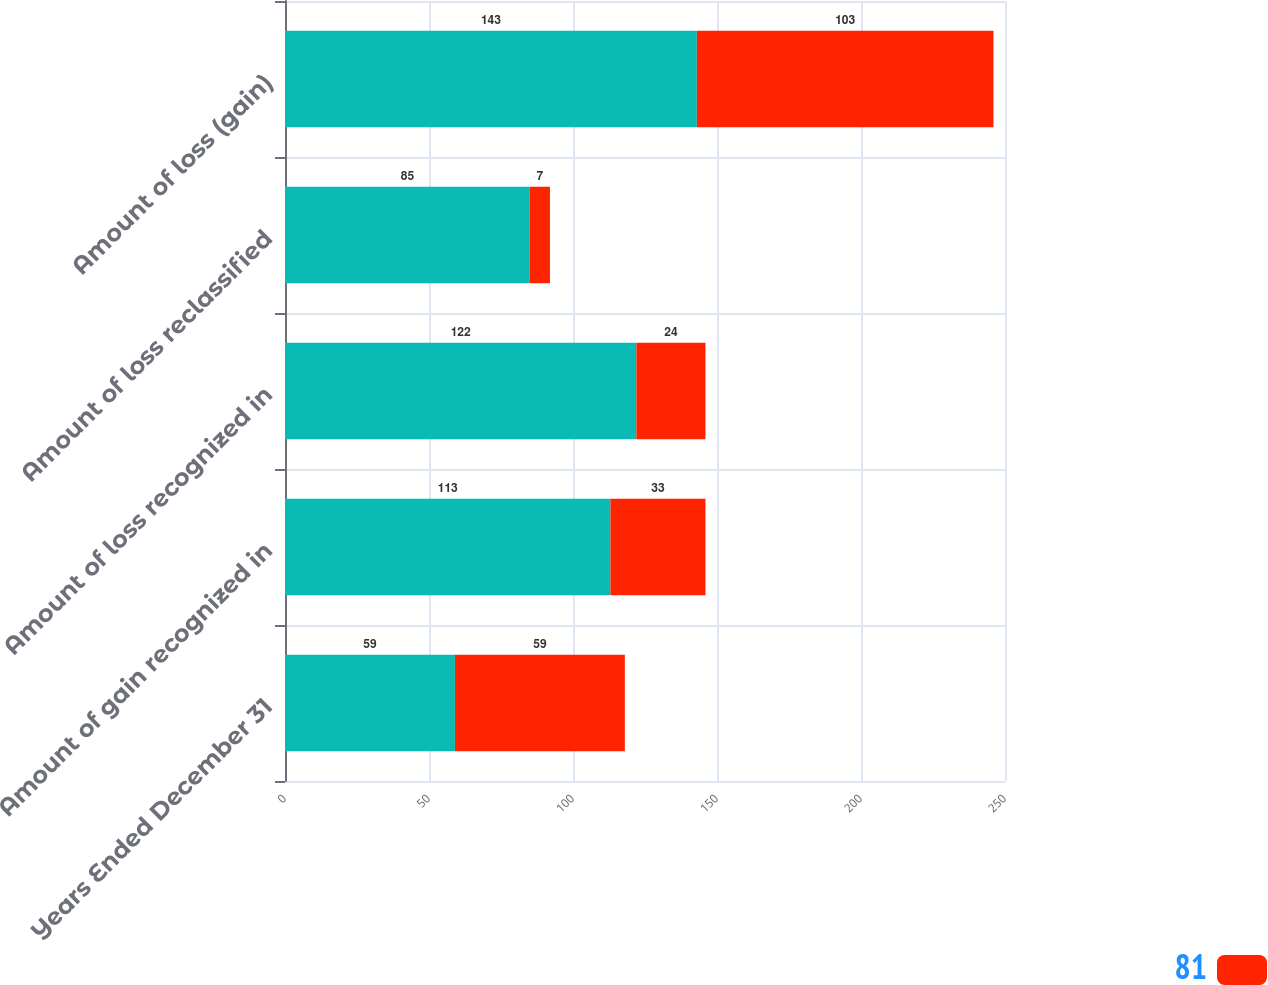Convert chart. <chart><loc_0><loc_0><loc_500><loc_500><stacked_bar_chart><ecel><fcel>Years Ended December 31<fcel>Amount of gain recognized in<fcel>Amount of loss recognized in<fcel>Amount of loss reclassified<fcel>Amount of loss (gain)<nl><fcel>nan<fcel>59<fcel>113<fcel>122<fcel>85<fcel>143<nl><fcel>81<fcel>59<fcel>33<fcel>24<fcel>7<fcel>103<nl></chart> 